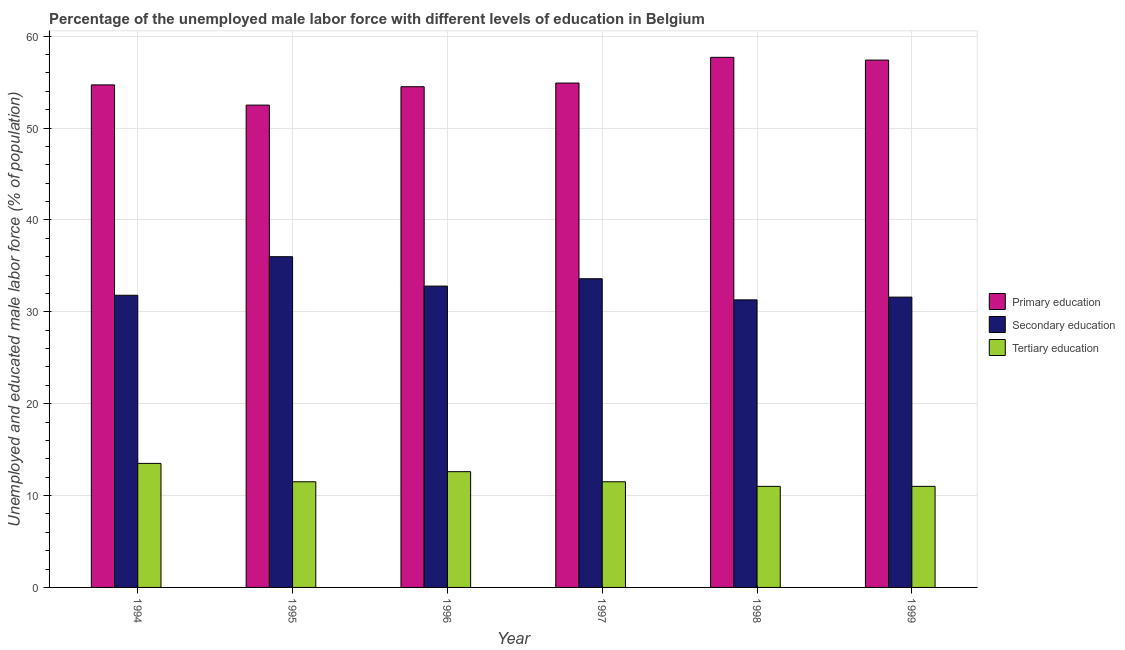Are the number of bars per tick equal to the number of legend labels?
Your answer should be compact. Yes. Are the number of bars on each tick of the X-axis equal?
Your response must be concise. Yes. How many bars are there on the 2nd tick from the right?
Your response must be concise. 3. What is the percentage of male labor force who received secondary education in 1999?
Provide a short and direct response. 31.6. What is the total percentage of male labor force who received tertiary education in the graph?
Your answer should be very brief. 71.1. What is the difference between the percentage of male labor force who received secondary education in 1996 and that in 1998?
Give a very brief answer. 1.5. What is the average percentage of male labor force who received primary education per year?
Offer a terse response. 55.28. What is the ratio of the percentage of male labor force who received secondary education in 1995 to that in 1999?
Your response must be concise. 1.14. Is the difference between the percentage of male labor force who received primary education in 1995 and 1997 greater than the difference between the percentage of male labor force who received secondary education in 1995 and 1997?
Offer a terse response. No. What is the difference between the highest and the second highest percentage of male labor force who received primary education?
Your answer should be compact. 0.3. What is the difference between the highest and the lowest percentage of male labor force who received primary education?
Ensure brevity in your answer.  5.2. Is the sum of the percentage of male labor force who received primary education in 1997 and 1999 greater than the maximum percentage of male labor force who received secondary education across all years?
Your answer should be compact. Yes. What does the 2nd bar from the left in 1995 represents?
Offer a terse response. Secondary education. What does the 2nd bar from the right in 1999 represents?
Ensure brevity in your answer.  Secondary education. Is it the case that in every year, the sum of the percentage of male labor force who received primary education and percentage of male labor force who received secondary education is greater than the percentage of male labor force who received tertiary education?
Give a very brief answer. Yes. Are all the bars in the graph horizontal?
Provide a short and direct response. No. How many years are there in the graph?
Your answer should be compact. 6. What is the difference between two consecutive major ticks on the Y-axis?
Offer a very short reply. 10. Are the values on the major ticks of Y-axis written in scientific E-notation?
Your response must be concise. No. Does the graph contain any zero values?
Provide a short and direct response. No. Does the graph contain grids?
Your answer should be compact. Yes. Where does the legend appear in the graph?
Your answer should be compact. Center right. What is the title of the graph?
Give a very brief answer. Percentage of the unemployed male labor force with different levels of education in Belgium. What is the label or title of the X-axis?
Your answer should be very brief. Year. What is the label or title of the Y-axis?
Your answer should be compact. Unemployed and educated male labor force (% of population). What is the Unemployed and educated male labor force (% of population) in Primary education in 1994?
Provide a succinct answer. 54.7. What is the Unemployed and educated male labor force (% of population) in Secondary education in 1994?
Keep it short and to the point. 31.8. What is the Unemployed and educated male labor force (% of population) of Tertiary education in 1994?
Provide a succinct answer. 13.5. What is the Unemployed and educated male labor force (% of population) in Primary education in 1995?
Provide a succinct answer. 52.5. What is the Unemployed and educated male labor force (% of population) in Secondary education in 1995?
Offer a terse response. 36. What is the Unemployed and educated male labor force (% of population) in Tertiary education in 1995?
Offer a very short reply. 11.5. What is the Unemployed and educated male labor force (% of population) in Primary education in 1996?
Ensure brevity in your answer.  54.5. What is the Unemployed and educated male labor force (% of population) in Secondary education in 1996?
Your answer should be very brief. 32.8. What is the Unemployed and educated male labor force (% of population) of Tertiary education in 1996?
Provide a succinct answer. 12.6. What is the Unemployed and educated male labor force (% of population) of Primary education in 1997?
Keep it short and to the point. 54.9. What is the Unemployed and educated male labor force (% of population) in Secondary education in 1997?
Offer a very short reply. 33.6. What is the Unemployed and educated male labor force (% of population) in Tertiary education in 1997?
Offer a very short reply. 11.5. What is the Unemployed and educated male labor force (% of population) of Primary education in 1998?
Provide a succinct answer. 57.7. What is the Unemployed and educated male labor force (% of population) of Secondary education in 1998?
Ensure brevity in your answer.  31.3. What is the Unemployed and educated male labor force (% of population) of Tertiary education in 1998?
Your answer should be very brief. 11. What is the Unemployed and educated male labor force (% of population) of Primary education in 1999?
Offer a very short reply. 57.4. What is the Unemployed and educated male labor force (% of population) in Secondary education in 1999?
Provide a succinct answer. 31.6. What is the Unemployed and educated male labor force (% of population) in Tertiary education in 1999?
Offer a terse response. 11. Across all years, what is the maximum Unemployed and educated male labor force (% of population) in Primary education?
Offer a very short reply. 57.7. Across all years, what is the maximum Unemployed and educated male labor force (% of population) of Secondary education?
Ensure brevity in your answer.  36. Across all years, what is the minimum Unemployed and educated male labor force (% of population) of Primary education?
Ensure brevity in your answer.  52.5. Across all years, what is the minimum Unemployed and educated male labor force (% of population) of Secondary education?
Your answer should be very brief. 31.3. Across all years, what is the minimum Unemployed and educated male labor force (% of population) of Tertiary education?
Give a very brief answer. 11. What is the total Unemployed and educated male labor force (% of population) in Primary education in the graph?
Provide a short and direct response. 331.7. What is the total Unemployed and educated male labor force (% of population) of Secondary education in the graph?
Ensure brevity in your answer.  197.1. What is the total Unemployed and educated male labor force (% of population) of Tertiary education in the graph?
Provide a short and direct response. 71.1. What is the difference between the Unemployed and educated male labor force (% of population) in Primary education in 1994 and that in 1995?
Your answer should be compact. 2.2. What is the difference between the Unemployed and educated male labor force (% of population) of Secondary education in 1994 and that in 1995?
Provide a short and direct response. -4.2. What is the difference between the Unemployed and educated male labor force (% of population) of Primary education in 1994 and that in 1996?
Make the answer very short. 0.2. What is the difference between the Unemployed and educated male labor force (% of population) in Tertiary education in 1994 and that in 1996?
Provide a short and direct response. 0.9. What is the difference between the Unemployed and educated male labor force (% of population) of Primary education in 1994 and that in 1997?
Keep it short and to the point. -0.2. What is the difference between the Unemployed and educated male labor force (% of population) in Tertiary education in 1994 and that in 1997?
Provide a succinct answer. 2. What is the difference between the Unemployed and educated male labor force (% of population) in Secondary education in 1994 and that in 1998?
Your response must be concise. 0.5. What is the difference between the Unemployed and educated male labor force (% of population) in Tertiary education in 1994 and that in 1998?
Make the answer very short. 2.5. What is the difference between the Unemployed and educated male labor force (% of population) of Secondary education in 1994 and that in 1999?
Provide a short and direct response. 0.2. What is the difference between the Unemployed and educated male labor force (% of population) in Tertiary education in 1994 and that in 1999?
Give a very brief answer. 2.5. What is the difference between the Unemployed and educated male labor force (% of population) of Primary education in 1995 and that in 1996?
Ensure brevity in your answer.  -2. What is the difference between the Unemployed and educated male labor force (% of population) in Secondary education in 1995 and that in 1996?
Provide a short and direct response. 3.2. What is the difference between the Unemployed and educated male labor force (% of population) of Tertiary education in 1995 and that in 1996?
Ensure brevity in your answer.  -1.1. What is the difference between the Unemployed and educated male labor force (% of population) in Primary education in 1995 and that in 1998?
Your answer should be compact. -5.2. What is the difference between the Unemployed and educated male labor force (% of population) of Secondary education in 1995 and that in 1998?
Your answer should be very brief. 4.7. What is the difference between the Unemployed and educated male labor force (% of population) in Tertiary education in 1995 and that in 1998?
Provide a succinct answer. 0.5. What is the difference between the Unemployed and educated male labor force (% of population) in Secondary education in 1995 and that in 1999?
Provide a short and direct response. 4.4. What is the difference between the Unemployed and educated male labor force (% of population) of Tertiary education in 1995 and that in 1999?
Provide a short and direct response. 0.5. What is the difference between the Unemployed and educated male labor force (% of population) of Primary education in 1996 and that in 1997?
Offer a terse response. -0.4. What is the difference between the Unemployed and educated male labor force (% of population) in Secondary education in 1996 and that in 1997?
Keep it short and to the point. -0.8. What is the difference between the Unemployed and educated male labor force (% of population) of Tertiary education in 1996 and that in 1997?
Provide a short and direct response. 1.1. What is the difference between the Unemployed and educated male labor force (% of population) in Tertiary education in 1996 and that in 1999?
Ensure brevity in your answer.  1.6. What is the difference between the Unemployed and educated male labor force (% of population) of Primary education in 1997 and that in 1999?
Your answer should be compact. -2.5. What is the difference between the Unemployed and educated male labor force (% of population) in Tertiary education in 1998 and that in 1999?
Offer a terse response. 0. What is the difference between the Unemployed and educated male labor force (% of population) in Primary education in 1994 and the Unemployed and educated male labor force (% of population) in Tertiary education in 1995?
Keep it short and to the point. 43.2. What is the difference between the Unemployed and educated male labor force (% of population) in Secondary education in 1994 and the Unemployed and educated male labor force (% of population) in Tertiary education in 1995?
Ensure brevity in your answer.  20.3. What is the difference between the Unemployed and educated male labor force (% of population) of Primary education in 1994 and the Unemployed and educated male labor force (% of population) of Secondary education in 1996?
Your answer should be compact. 21.9. What is the difference between the Unemployed and educated male labor force (% of population) of Primary education in 1994 and the Unemployed and educated male labor force (% of population) of Tertiary education in 1996?
Offer a very short reply. 42.1. What is the difference between the Unemployed and educated male labor force (% of population) in Secondary education in 1994 and the Unemployed and educated male labor force (% of population) in Tertiary education in 1996?
Offer a very short reply. 19.2. What is the difference between the Unemployed and educated male labor force (% of population) in Primary education in 1994 and the Unemployed and educated male labor force (% of population) in Secondary education in 1997?
Ensure brevity in your answer.  21.1. What is the difference between the Unemployed and educated male labor force (% of population) of Primary education in 1994 and the Unemployed and educated male labor force (% of population) of Tertiary education in 1997?
Offer a terse response. 43.2. What is the difference between the Unemployed and educated male labor force (% of population) of Secondary education in 1994 and the Unemployed and educated male labor force (% of population) of Tertiary education in 1997?
Your response must be concise. 20.3. What is the difference between the Unemployed and educated male labor force (% of population) of Primary education in 1994 and the Unemployed and educated male labor force (% of population) of Secondary education in 1998?
Keep it short and to the point. 23.4. What is the difference between the Unemployed and educated male labor force (% of population) in Primary education in 1994 and the Unemployed and educated male labor force (% of population) in Tertiary education in 1998?
Provide a succinct answer. 43.7. What is the difference between the Unemployed and educated male labor force (% of population) in Secondary education in 1994 and the Unemployed and educated male labor force (% of population) in Tertiary education in 1998?
Provide a succinct answer. 20.8. What is the difference between the Unemployed and educated male labor force (% of population) of Primary education in 1994 and the Unemployed and educated male labor force (% of population) of Secondary education in 1999?
Give a very brief answer. 23.1. What is the difference between the Unemployed and educated male labor force (% of population) in Primary education in 1994 and the Unemployed and educated male labor force (% of population) in Tertiary education in 1999?
Provide a short and direct response. 43.7. What is the difference between the Unemployed and educated male labor force (% of population) of Secondary education in 1994 and the Unemployed and educated male labor force (% of population) of Tertiary education in 1999?
Provide a succinct answer. 20.8. What is the difference between the Unemployed and educated male labor force (% of population) in Primary education in 1995 and the Unemployed and educated male labor force (% of population) in Tertiary education in 1996?
Offer a terse response. 39.9. What is the difference between the Unemployed and educated male labor force (% of population) in Secondary education in 1995 and the Unemployed and educated male labor force (% of population) in Tertiary education in 1996?
Make the answer very short. 23.4. What is the difference between the Unemployed and educated male labor force (% of population) in Primary education in 1995 and the Unemployed and educated male labor force (% of population) in Secondary education in 1997?
Provide a short and direct response. 18.9. What is the difference between the Unemployed and educated male labor force (% of population) of Primary education in 1995 and the Unemployed and educated male labor force (% of population) of Secondary education in 1998?
Your answer should be very brief. 21.2. What is the difference between the Unemployed and educated male labor force (% of population) of Primary education in 1995 and the Unemployed and educated male labor force (% of population) of Tertiary education in 1998?
Give a very brief answer. 41.5. What is the difference between the Unemployed and educated male labor force (% of population) of Secondary education in 1995 and the Unemployed and educated male labor force (% of population) of Tertiary education in 1998?
Keep it short and to the point. 25. What is the difference between the Unemployed and educated male labor force (% of population) of Primary education in 1995 and the Unemployed and educated male labor force (% of population) of Secondary education in 1999?
Offer a terse response. 20.9. What is the difference between the Unemployed and educated male labor force (% of population) of Primary education in 1995 and the Unemployed and educated male labor force (% of population) of Tertiary education in 1999?
Ensure brevity in your answer.  41.5. What is the difference between the Unemployed and educated male labor force (% of population) of Secondary education in 1995 and the Unemployed and educated male labor force (% of population) of Tertiary education in 1999?
Your answer should be compact. 25. What is the difference between the Unemployed and educated male labor force (% of population) of Primary education in 1996 and the Unemployed and educated male labor force (% of population) of Secondary education in 1997?
Offer a very short reply. 20.9. What is the difference between the Unemployed and educated male labor force (% of population) in Primary education in 1996 and the Unemployed and educated male labor force (% of population) in Tertiary education in 1997?
Your response must be concise. 43. What is the difference between the Unemployed and educated male labor force (% of population) of Secondary education in 1996 and the Unemployed and educated male labor force (% of population) of Tertiary education in 1997?
Your answer should be compact. 21.3. What is the difference between the Unemployed and educated male labor force (% of population) in Primary education in 1996 and the Unemployed and educated male labor force (% of population) in Secondary education in 1998?
Make the answer very short. 23.2. What is the difference between the Unemployed and educated male labor force (% of population) in Primary education in 1996 and the Unemployed and educated male labor force (% of population) in Tertiary education in 1998?
Your answer should be compact. 43.5. What is the difference between the Unemployed and educated male labor force (% of population) in Secondary education in 1996 and the Unemployed and educated male labor force (% of population) in Tertiary education in 1998?
Offer a very short reply. 21.8. What is the difference between the Unemployed and educated male labor force (% of population) in Primary education in 1996 and the Unemployed and educated male labor force (% of population) in Secondary education in 1999?
Make the answer very short. 22.9. What is the difference between the Unemployed and educated male labor force (% of population) of Primary education in 1996 and the Unemployed and educated male labor force (% of population) of Tertiary education in 1999?
Offer a very short reply. 43.5. What is the difference between the Unemployed and educated male labor force (% of population) in Secondary education in 1996 and the Unemployed and educated male labor force (% of population) in Tertiary education in 1999?
Your answer should be compact. 21.8. What is the difference between the Unemployed and educated male labor force (% of population) of Primary education in 1997 and the Unemployed and educated male labor force (% of population) of Secondary education in 1998?
Your response must be concise. 23.6. What is the difference between the Unemployed and educated male labor force (% of population) in Primary education in 1997 and the Unemployed and educated male labor force (% of population) in Tertiary education in 1998?
Your response must be concise. 43.9. What is the difference between the Unemployed and educated male labor force (% of population) of Secondary education in 1997 and the Unemployed and educated male labor force (% of population) of Tertiary education in 1998?
Your answer should be very brief. 22.6. What is the difference between the Unemployed and educated male labor force (% of population) in Primary education in 1997 and the Unemployed and educated male labor force (% of population) in Secondary education in 1999?
Offer a very short reply. 23.3. What is the difference between the Unemployed and educated male labor force (% of population) in Primary education in 1997 and the Unemployed and educated male labor force (% of population) in Tertiary education in 1999?
Provide a succinct answer. 43.9. What is the difference between the Unemployed and educated male labor force (% of population) in Secondary education in 1997 and the Unemployed and educated male labor force (% of population) in Tertiary education in 1999?
Your response must be concise. 22.6. What is the difference between the Unemployed and educated male labor force (% of population) in Primary education in 1998 and the Unemployed and educated male labor force (% of population) in Secondary education in 1999?
Your response must be concise. 26.1. What is the difference between the Unemployed and educated male labor force (% of population) in Primary education in 1998 and the Unemployed and educated male labor force (% of population) in Tertiary education in 1999?
Your answer should be very brief. 46.7. What is the difference between the Unemployed and educated male labor force (% of population) in Secondary education in 1998 and the Unemployed and educated male labor force (% of population) in Tertiary education in 1999?
Your answer should be compact. 20.3. What is the average Unemployed and educated male labor force (% of population) of Primary education per year?
Your answer should be compact. 55.28. What is the average Unemployed and educated male labor force (% of population) of Secondary education per year?
Ensure brevity in your answer.  32.85. What is the average Unemployed and educated male labor force (% of population) in Tertiary education per year?
Your answer should be very brief. 11.85. In the year 1994, what is the difference between the Unemployed and educated male labor force (% of population) of Primary education and Unemployed and educated male labor force (% of population) of Secondary education?
Your answer should be very brief. 22.9. In the year 1994, what is the difference between the Unemployed and educated male labor force (% of population) of Primary education and Unemployed and educated male labor force (% of population) of Tertiary education?
Offer a very short reply. 41.2. In the year 1994, what is the difference between the Unemployed and educated male labor force (% of population) in Secondary education and Unemployed and educated male labor force (% of population) in Tertiary education?
Make the answer very short. 18.3. In the year 1995, what is the difference between the Unemployed and educated male labor force (% of population) of Primary education and Unemployed and educated male labor force (% of population) of Secondary education?
Make the answer very short. 16.5. In the year 1995, what is the difference between the Unemployed and educated male labor force (% of population) of Primary education and Unemployed and educated male labor force (% of population) of Tertiary education?
Make the answer very short. 41. In the year 1996, what is the difference between the Unemployed and educated male labor force (% of population) of Primary education and Unemployed and educated male labor force (% of population) of Secondary education?
Your answer should be compact. 21.7. In the year 1996, what is the difference between the Unemployed and educated male labor force (% of population) in Primary education and Unemployed and educated male labor force (% of population) in Tertiary education?
Provide a short and direct response. 41.9. In the year 1996, what is the difference between the Unemployed and educated male labor force (% of population) of Secondary education and Unemployed and educated male labor force (% of population) of Tertiary education?
Your answer should be compact. 20.2. In the year 1997, what is the difference between the Unemployed and educated male labor force (% of population) in Primary education and Unemployed and educated male labor force (% of population) in Secondary education?
Make the answer very short. 21.3. In the year 1997, what is the difference between the Unemployed and educated male labor force (% of population) of Primary education and Unemployed and educated male labor force (% of population) of Tertiary education?
Ensure brevity in your answer.  43.4. In the year 1997, what is the difference between the Unemployed and educated male labor force (% of population) in Secondary education and Unemployed and educated male labor force (% of population) in Tertiary education?
Provide a short and direct response. 22.1. In the year 1998, what is the difference between the Unemployed and educated male labor force (% of population) of Primary education and Unemployed and educated male labor force (% of population) of Secondary education?
Your response must be concise. 26.4. In the year 1998, what is the difference between the Unemployed and educated male labor force (% of population) in Primary education and Unemployed and educated male labor force (% of population) in Tertiary education?
Your answer should be very brief. 46.7. In the year 1998, what is the difference between the Unemployed and educated male labor force (% of population) in Secondary education and Unemployed and educated male labor force (% of population) in Tertiary education?
Offer a terse response. 20.3. In the year 1999, what is the difference between the Unemployed and educated male labor force (% of population) of Primary education and Unemployed and educated male labor force (% of population) of Secondary education?
Give a very brief answer. 25.8. In the year 1999, what is the difference between the Unemployed and educated male labor force (% of population) of Primary education and Unemployed and educated male labor force (% of population) of Tertiary education?
Provide a succinct answer. 46.4. In the year 1999, what is the difference between the Unemployed and educated male labor force (% of population) in Secondary education and Unemployed and educated male labor force (% of population) in Tertiary education?
Your answer should be compact. 20.6. What is the ratio of the Unemployed and educated male labor force (% of population) in Primary education in 1994 to that in 1995?
Offer a very short reply. 1.04. What is the ratio of the Unemployed and educated male labor force (% of population) in Secondary education in 1994 to that in 1995?
Keep it short and to the point. 0.88. What is the ratio of the Unemployed and educated male labor force (% of population) of Tertiary education in 1994 to that in 1995?
Your response must be concise. 1.17. What is the ratio of the Unemployed and educated male labor force (% of population) of Primary education in 1994 to that in 1996?
Your response must be concise. 1. What is the ratio of the Unemployed and educated male labor force (% of population) in Secondary education in 1994 to that in 1996?
Your answer should be very brief. 0.97. What is the ratio of the Unemployed and educated male labor force (% of population) of Tertiary education in 1994 to that in 1996?
Offer a very short reply. 1.07. What is the ratio of the Unemployed and educated male labor force (% of population) in Secondary education in 1994 to that in 1997?
Keep it short and to the point. 0.95. What is the ratio of the Unemployed and educated male labor force (% of population) of Tertiary education in 1994 to that in 1997?
Offer a terse response. 1.17. What is the ratio of the Unemployed and educated male labor force (% of population) of Primary education in 1994 to that in 1998?
Your answer should be very brief. 0.95. What is the ratio of the Unemployed and educated male labor force (% of population) in Secondary education in 1994 to that in 1998?
Ensure brevity in your answer.  1.02. What is the ratio of the Unemployed and educated male labor force (% of population) in Tertiary education in 1994 to that in 1998?
Your answer should be very brief. 1.23. What is the ratio of the Unemployed and educated male labor force (% of population) in Primary education in 1994 to that in 1999?
Keep it short and to the point. 0.95. What is the ratio of the Unemployed and educated male labor force (% of population) in Tertiary education in 1994 to that in 1999?
Make the answer very short. 1.23. What is the ratio of the Unemployed and educated male labor force (% of population) of Primary education in 1995 to that in 1996?
Keep it short and to the point. 0.96. What is the ratio of the Unemployed and educated male labor force (% of population) in Secondary education in 1995 to that in 1996?
Your answer should be very brief. 1.1. What is the ratio of the Unemployed and educated male labor force (% of population) in Tertiary education in 1995 to that in 1996?
Offer a very short reply. 0.91. What is the ratio of the Unemployed and educated male labor force (% of population) of Primary education in 1995 to that in 1997?
Your answer should be very brief. 0.96. What is the ratio of the Unemployed and educated male labor force (% of population) in Secondary education in 1995 to that in 1997?
Keep it short and to the point. 1.07. What is the ratio of the Unemployed and educated male labor force (% of population) of Tertiary education in 1995 to that in 1997?
Provide a succinct answer. 1. What is the ratio of the Unemployed and educated male labor force (% of population) of Primary education in 1995 to that in 1998?
Give a very brief answer. 0.91. What is the ratio of the Unemployed and educated male labor force (% of population) in Secondary education in 1995 to that in 1998?
Your response must be concise. 1.15. What is the ratio of the Unemployed and educated male labor force (% of population) of Tertiary education in 1995 to that in 1998?
Your answer should be compact. 1.05. What is the ratio of the Unemployed and educated male labor force (% of population) in Primary education in 1995 to that in 1999?
Make the answer very short. 0.91. What is the ratio of the Unemployed and educated male labor force (% of population) in Secondary education in 1995 to that in 1999?
Your answer should be compact. 1.14. What is the ratio of the Unemployed and educated male labor force (% of population) in Tertiary education in 1995 to that in 1999?
Your answer should be compact. 1.05. What is the ratio of the Unemployed and educated male labor force (% of population) in Primary education in 1996 to that in 1997?
Your answer should be compact. 0.99. What is the ratio of the Unemployed and educated male labor force (% of population) in Secondary education in 1996 to that in 1997?
Your answer should be compact. 0.98. What is the ratio of the Unemployed and educated male labor force (% of population) in Tertiary education in 1996 to that in 1997?
Keep it short and to the point. 1.1. What is the ratio of the Unemployed and educated male labor force (% of population) of Primary education in 1996 to that in 1998?
Offer a terse response. 0.94. What is the ratio of the Unemployed and educated male labor force (% of population) of Secondary education in 1996 to that in 1998?
Give a very brief answer. 1.05. What is the ratio of the Unemployed and educated male labor force (% of population) of Tertiary education in 1996 to that in 1998?
Give a very brief answer. 1.15. What is the ratio of the Unemployed and educated male labor force (% of population) in Primary education in 1996 to that in 1999?
Offer a terse response. 0.95. What is the ratio of the Unemployed and educated male labor force (% of population) in Secondary education in 1996 to that in 1999?
Provide a succinct answer. 1.04. What is the ratio of the Unemployed and educated male labor force (% of population) of Tertiary education in 1996 to that in 1999?
Offer a terse response. 1.15. What is the ratio of the Unemployed and educated male labor force (% of population) of Primary education in 1997 to that in 1998?
Your answer should be compact. 0.95. What is the ratio of the Unemployed and educated male labor force (% of population) in Secondary education in 1997 to that in 1998?
Offer a terse response. 1.07. What is the ratio of the Unemployed and educated male labor force (% of population) of Tertiary education in 1997 to that in 1998?
Your response must be concise. 1.05. What is the ratio of the Unemployed and educated male labor force (% of population) of Primary education in 1997 to that in 1999?
Ensure brevity in your answer.  0.96. What is the ratio of the Unemployed and educated male labor force (% of population) of Secondary education in 1997 to that in 1999?
Your response must be concise. 1.06. What is the ratio of the Unemployed and educated male labor force (% of population) of Tertiary education in 1997 to that in 1999?
Your answer should be compact. 1.05. What is the ratio of the Unemployed and educated male labor force (% of population) of Tertiary education in 1998 to that in 1999?
Make the answer very short. 1. What is the difference between the highest and the second highest Unemployed and educated male labor force (% of population) in Primary education?
Offer a very short reply. 0.3. What is the difference between the highest and the second highest Unemployed and educated male labor force (% of population) in Secondary education?
Your answer should be compact. 2.4. What is the difference between the highest and the second highest Unemployed and educated male labor force (% of population) of Tertiary education?
Give a very brief answer. 0.9. What is the difference between the highest and the lowest Unemployed and educated male labor force (% of population) of Tertiary education?
Give a very brief answer. 2.5. 